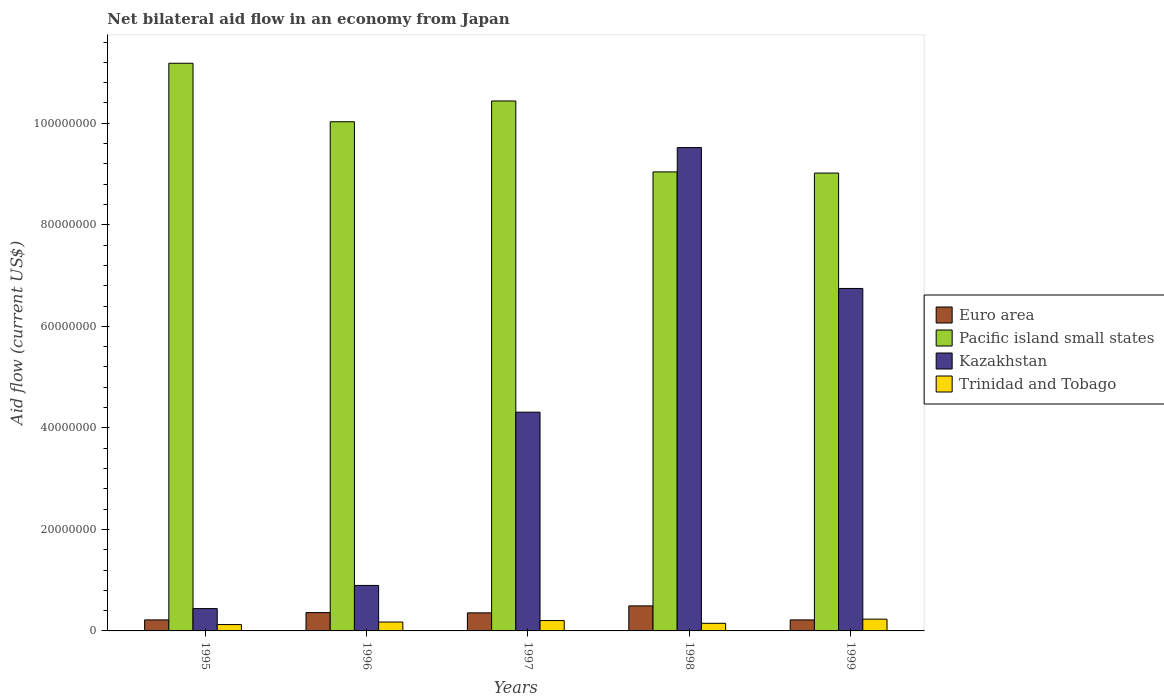How many different coloured bars are there?
Your answer should be compact. 4. How many groups of bars are there?
Offer a terse response. 5. Are the number of bars per tick equal to the number of legend labels?
Provide a succinct answer. Yes. Are the number of bars on each tick of the X-axis equal?
Make the answer very short. Yes. What is the net bilateral aid flow in Kazakhstan in 1996?
Your response must be concise. 8.96e+06. Across all years, what is the maximum net bilateral aid flow in Pacific island small states?
Make the answer very short. 1.12e+08. Across all years, what is the minimum net bilateral aid flow in Trinidad and Tobago?
Keep it short and to the point. 1.25e+06. In which year was the net bilateral aid flow in Kazakhstan maximum?
Give a very brief answer. 1998. What is the total net bilateral aid flow in Kazakhstan in the graph?
Ensure brevity in your answer.  2.19e+08. What is the difference between the net bilateral aid flow in Trinidad and Tobago in 1995 and that in 1997?
Offer a very short reply. -7.90e+05. What is the difference between the net bilateral aid flow in Pacific island small states in 1997 and the net bilateral aid flow in Kazakhstan in 1995?
Your response must be concise. 1.00e+08. What is the average net bilateral aid flow in Trinidad and Tobago per year?
Keep it short and to the point. 1.77e+06. What is the ratio of the net bilateral aid flow in Pacific island small states in 1997 to that in 1999?
Make the answer very short. 1.16. Is the net bilateral aid flow in Trinidad and Tobago in 1995 less than that in 1996?
Ensure brevity in your answer.  Yes. Is the difference between the net bilateral aid flow in Euro area in 1995 and 1998 greater than the difference between the net bilateral aid flow in Trinidad and Tobago in 1995 and 1998?
Offer a terse response. No. What is the difference between the highest and the second highest net bilateral aid flow in Pacific island small states?
Ensure brevity in your answer.  7.43e+06. What is the difference between the highest and the lowest net bilateral aid flow in Trinidad and Tobago?
Keep it short and to the point. 1.07e+06. What does the 4th bar from the left in 1998 represents?
Provide a succinct answer. Trinidad and Tobago. What does the 1st bar from the right in 1995 represents?
Provide a short and direct response. Trinidad and Tobago. How many bars are there?
Your answer should be compact. 20. Does the graph contain any zero values?
Provide a short and direct response. No. Does the graph contain grids?
Keep it short and to the point. No. What is the title of the graph?
Give a very brief answer. Net bilateral aid flow in an economy from Japan. Does "Norway" appear as one of the legend labels in the graph?
Provide a short and direct response. No. What is the label or title of the X-axis?
Provide a succinct answer. Years. What is the label or title of the Y-axis?
Your response must be concise. Aid flow (current US$). What is the Aid flow (current US$) of Euro area in 1995?
Ensure brevity in your answer.  2.17e+06. What is the Aid flow (current US$) in Pacific island small states in 1995?
Offer a terse response. 1.12e+08. What is the Aid flow (current US$) of Kazakhstan in 1995?
Provide a succinct answer. 4.40e+06. What is the Aid flow (current US$) in Trinidad and Tobago in 1995?
Ensure brevity in your answer.  1.25e+06. What is the Aid flow (current US$) in Euro area in 1996?
Provide a succinct answer. 3.61e+06. What is the Aid flow (current US$) in Pacific island small states in 1996?
Offer a terse response. 1.00e+08. What is the Aid flow (current US$) in Kazakhstan in 1996?
Ensure brevity in your answer.  8.96e+06. What is the Aid flow (current US$) in Trinidad and Tobago in 1996?
Provide a short and direct response. 1.75e+06. What is the Aid flow (current US$) in Euro area in 1997?
Your response must be concise. 3.56e+06. What is the Aid flow (current US$) in Pacific island small states in 1997?
Keep it short and to the point. 1.04e+08. What is the Aid flow (current US$) in Kazakhstan in 1997?
Ensure brevity in your answer.  4.31e+07. What is the Aid flow (current US$) in Trinidad and Tobago in 1997?
Your answer should be very brief. 2.04e+06. What is the Aid flow (current US$) of Euro area in 1998?
Keep it short and to the point. 4.93e+06. What is the Aid flow (current US$) in Pacific island small states in 1998?
Provide a succinct answer. 9.04e+07. What is the Aid flow (current US$) in Kazakhstan in 1998?
Ensure brevity in your answer.  9.52e+07. What is the Aid flow (current US$) in Trinidad and Tobago in 1998?
Provide a succinct answer. 1.50e+06. What is the Aid flow (current US$) of Euro area in 1999?
Make the answer very short. 2.17e+06. What is the Aid flow (current US$) of Pacific island small states in 1999?
Offer a very short reply. 9.02e+07. What is the Aid flow (current US$) in Kazakhstan in 1999?
Provide a succinct answer. 6.75e+07. What is the Aid flow (current US$) of Trinidad and Tobago in 1999?
Your answer should be very brief. 2.32e+06. Across all years, what is the maximum Aid flow (current US$) in Euro area?
Offer a terse response. 4.93e+06. Across all years, what is the maximum Aid flow (current US$) in Pacific island small states?
Ensure brevity in your answer.  1.12e+08. Across all years, what is the maximum Aid flow (current US$) of Kazakhstan?
Your answer should be very brief. 9.52e+07. Across all years, what is the maximum Aid flow (current US$) in Trinidad and Tobago?
Offer a very short reply. 2.32e+06. Across all years, what is the minimum Aid flow (current US$) in Euro area?
Keep it short and to the point. 2.17e+06. Across all years, what is the minimum Aid flow (current US$) in Pacific island small states?
Your answer should be compact. 9.02e+07. Across all years, what is the minimum Aid flow (current US$) of Kazakhstan?
Provide a short and direct response. 4.40e+06. Across all years, what is the minimum Aid flow (current US$) of Trinidad and Tobago?
Ensure brevity in your answer.  1.25e+06. What is the total Aid flow (current US$) in Euro area in the graph?
Your answer should be compact. 1.64e+07. What is the total Aid flow (current US$) in Pacific island small states in the graph?
Provide a succinct answer. 4.97e+08. What is the total Aid flow (current US$) of Kazakhstan in the graph?
Your answer should be very brief. 2.19e+08. What is the total Aid flow (current US$) in Trinidad and Tobago in the graph?
Your response must be concise. 8.86e+06. What is the difference between the Aid flow (current US$) in Euro area in 1995 and that in 1996?
Offer a very short reply. -1.44e+06. What is the difference between the Aid flow (current US$) of Pacific island small states in 1995 and that in 1996?
Ensure brevity in your answer.  1.15e+07. What is the difference between the Aid flow (current US$) of Kazakhstan in 1995 and that in 1996?
Your answer should be very brief. -4.56e+06. What is the difference between the Aid flow (current US$) in Trinidad and Tobago in 1995 and that in 1996?
Keep it short and to the point. -5.00e+05. What is the difference between the Aid flow (current US$) in Euro area in 1995 and that in 1997?
Offer a terse response. -1.39e+06. What is the difference between the Aid flow (current US$) in Pacific island small states in 1995 and that in 1997?
Give a very brief answer. 7.43e+06. What is the difference between the Aid flow (current US$) of Kazakhstan in 1995 and that in 1997?
Keep it short and to the point. -3.87e+07. What is the difference between the Aid flow (current US$) of Trinidad and Tobago in 1995 and that in 1997?
Offer a terse response. -7.90e+05. What is the difference between the Aid flow (current US$) in Euro area in 1995 and that in 1998?
Give a very brief answer. -2.76e+06. What is the difference between the Aid flow (current US$) of Pacific island small states in 1995 and that in 1998?
Your answer should be very brief. 2.14e+07. What is the difference between the Aid flow (current US$) of Kazakhstan in 1995 and that in 1998?
Your answer should be compact. -9.08e+07. What is the difference between the Aid flow (current US$) in Trinidad and Tobago in 1995 and that in 1998?
Provide a succinct answer. -2.50e+05. What is the difference between the Aid flow (current US$) of Pacific island small states in 1995 and that in 1999?
Provide a succinct answer. 2.16e+07. What is the difference between the Aid flow (current US$) of Kazakhstan in 1995 and that in 1999?
Your response must be concise. -6.31e+07. What is the difference between the Aid flow (current US$) of Trinidad and Tobago in 1995 and that in 1999?
Offer a terse response. -1.07e+06. What is the difference between the Aid flow (current US$) of Pacific island small states in 1996 and that in 1997?
Make the answer very short. -4.09e+06. What is the difference between the Aid flow (current US$) in Kazakhstan in 1996 and that in 1997?
Offer a very short reply. -3.41e+07. What is the difference between the Aid flow (current US$) in Euro area in 1996 and that in 1998?
Provide a succinct answer. -1.32e+06. What is the difference between the Aid flow (current US$) in Pacific island small states in 1996 and that in 1998?
Your response must be concise. 9.88e+06. What is the difference between the Aid flow (current US$) in Kazakhstan in 1996 and that in 1998?
Offer a terse response. -8.62e+07. What is the difference between the Aid flow (current US$) of Euro area in 1996 and that in 1999?
Give a very brief answer. 1.44e+06. What is the difference between the Aid flow (current US$) in Pacific island small states in 1996 and that in 1999?
Your answer should be compact. 1.01e+07. What is the difference between the Aid flow (current US$) in Kazakhstan in 1996 and that in 1999?
Provide a short and direct response. -5.85e+07. What is the difference between the Aid flow (current US$) of Trinidad and Tobago in 1996 and that in 1999?
Give a very brief answer. -5.70e+05. What is the difference between the Aid flow (current US$) of Euro area in 1997 and that in 1998?
Give a very brief answer. -1.37e+06. What is the difference between the Aid flow (current US$) in Pacific island small states in 1997 and that in 1998?
Provide a succinct answer. 1.40e+07. What is the difference between the Aid flow (current US$) of Kazakhstan in 1997 and that in 1998?
Your answer should be compact. -5.21e+07. What is the difference between the Aid flow (current US$) in Trinidad and Tobago in 1997 and that in 1998?
Offer a very short reply. 5.40e+05. What is the difference between the Aid flow (current US$) in Euro area in 1997 and that in 1999?
Provide a short and direct response. 1.39e+06. What is the difference between the Aid flow (current US$) of Pacific island small states in 1997 and that in 1999?
Provide a succinct answer. 1.42e+07. What is the difference between the Aid flow (current US$) in Kazakhstan in 1997 and that in 1999?
Give a very brief answer. -2.44e+07. What is the difference between the Aid flow (current US$) of Trinidad and Tobago in 1997 and that in 1999?
Provide a short and direct response. -2.80e+05. What is the difference between the Aid flow (current US$) in Euro area in 1998 and that in 1999?
Offer a terse response. 2.76e+06. What is the difference between the Aid flow (current US$) of Kazakhstan in 1998 and that in 1999?
Keep it short and to the point. 2.78e+07. What is the difference between the Aid flow (current US$) in Trinidad and Tobago in 1998 and that in 1999?
Your response must be concise. -8.20e+05. What is the difference between the Aid flow (current US$) in Euro area in 1995 and the Aid flow (current US$) in Pacific island small states in 1996?
Your response must be concise. -9.81e+07. What is the difference between the Aid flow (current US$) of Euro area in 1995 and the Aid flow (current US$) of Kazakhstan in 1996?
Provide a succinct answer. -6.79e+06. What is the difference between the Aid flow (current US$) of Euro area in 1995 and the Aid flow (current US$) of Trinidad and Tobago in 1996?
Your answer should be very brief. 4.20e+05. What is the difference between the Aid flow (current US$) in Pacific island small states in 1995 and the Aid flow (current US$) in Kazakhstan in 1996?
Your response must be concise. 1.03e+08. What is the difference between the Aid flow (current US$) of Pacific island small states in 1995 and the Aid flow (current US$) of Trinidad and Tobago in 1996?
Provide a short and direct response. 1.10e+08. What is the difference between the Aid flow (current US$) in Kazakhstan in 1995 and the Aid flow (current US$) in Trinidad and Tobago in 1996?
Give a very brief answer. 2.65e+06. What is the difference between the Aid flow (current US$) in Euro area in 1995 and the Aid flow (current US$) in Pacific island small states in 1997?
Your answer should be very brief. -1.02e+08. What is the difference between the Aid flow (current US$) of Euro area in 1995 and the Aid flow (current US$) of Kazakhstan in 1997?
Your answer should be very brief. -4.09e+07. What is the difference between the Aid flow (current US$) in Pacific island small states in 1995 and the Aid flow (current US$) in Kazakhstan in 1997?
Give a very brief answer. 6.87e+07. What is the difference between the Aid flow (current US$) of Pacific island small states in 1995 and the Aid flow (current US$) of Trinidad and Tobago in 1997?
Provide a short and direct response. 1.10e+08. What is the difference between the Aid flow (current US$) in Kazakhstan in 1995 and the Aid flow (current US$) in Trinidad and Tobago in 1997?
Keep it short and to the point. 2.36e+06. What is the difference between the Aid flow (current US$) of Euro area in 1995 and the Aid flow (current US$) of Pacific island small states in 1998?
Offer a terse response. -8.82e+07. What is the difference between the Aid flow (current US$) of Euro area in 1995 and the Aid flow (current US$) of Kazakhstan in 1998?
Ensure brevity in your answer.  -9.30e+07. What is the difference between the Aid flow (current US$) in Euro area in 1995 and the Aid flow (current US$) in Trinidad and Tobago in 1998?
Provide a succinct answer. 6.70e+05. What is the difference between the Aid flow (current US$) of Pacific island small states in 1995 and the Aid flow (current US$) of Kazakhstan in 1998?
Ensure brevity in your answer.  1.66e+07. What is the difference between the Aid flow (current US$) of Pacific island small states in 1995 and the Aid flow (current US$) of Trinidad and Tobago in 1998?
Ensure brevity in your answer.  1.10e+08. What is the difference between the Aid flow (current US$) of Kazakhstan in 1995 and the Aid flow (current US$) of Trinidad and Tobago in 1998?
Ensure brevity in your answer.  2.90e+06. What is the difference between the Aid flow (current US$) in Euro area in 1995 and the Aid flow (current US$) in Pacific island small states in 1999?
Your answer should be very brief. -8.80e+07. What is the difference between the Aid flow (current US$) in Euro area in 1995 and the Aid flow (current US$) in Kazakhstan in 1999?
Provide a succinct answer. -6.53e+07. What is the difference between the Aid flow (current US$) of Euro area in 1995 and the Aid flow (current US$) of Trinidad and Tobago in 1999?
Ensure brevity in your answer.  -1.50e+05. What is the difference between the Aid flow (current US$) in Pacific island small states in 1995 and the Aid flow (current US$) in Kazakhstan in 1999?
Your answer should be very brief. 4.44e+07. What is the difference between the Aid flow (current US$) of Pacific island small states in 1995 and the Aid flow (current US$) of Trinidad and Tobago in 1999?
Offer a terse response. 1.10e+08. What is the difference between the Aid flow (current US$) in Kazakhstan in 1995 and the Aid flow (current US$) in Trinidad and Tobago in 1999?
Keep it short and to the point. 2.08e+06. What is the difference between the Aid flow (current US$) in Euro area in 1996 and the Aid flow (current US$) in Pacific island small states in 1997?
Your answer should be compact. -1.01e+08. What is the difference between the Aid flow (current US$) in Euro area in 1996 and the Aid flow (current US$) in Kazakhstan in 1997?
Give a very brief answer. -3.95e+07. What is the difference between the Aid flow (current US$) in Euro area in 1996 and the Aid flow (current US$) in Trinidad and Tobago in 1997?
Your answer should be compact. 1.57e+06. What is the difference between the Aid flow (current US$) in Pacific island small states in 1996 and the Aid flow (current US$) in Kazakhstan in 1997?
Provide a short and direct response. 5.72e+07. What is the difference between the Aid flow (current US$) in Pacific island small states in 1996 and the Aid flow (current US$) in Trinidad and Tobago in 1997?
Offer a terse response. 9.83e+07. What is the difference between the Aid flow (current US$) of Kazakhstan in 1996 and the Aid flow (current US$) of Trinidad and Tobago in 1997?
Provide a succinct answer. 6.92e+06. What is the difference between the Aid flow (current US$) in Euro area in 1996 and the Aid flow (current US$) in Pacific island small states in 1998?
Provide a succinct answer. -8.68e+07. What is the difference between the Aid flow (current US$) in Euro area in 1996 and the Aid flow (current US$) in Kazakhstan in 1998?
Ensure brevity in your answer.  -9.16e+07. What is the difference between the Aid flow (current US$) of Euro area in 1996 and the Aid flow (current US$) of Trinidad and Tobago in 1998?
Ensure brevity in your answer.  2.11e+06. What is the difference between the Aid flow (current US$) in Pacific island small states in 1996 and the Aid flow (current US$) in Kazakhstan in 1998?
Your answer should be compact. 5.09e+06. What is the difference between the Aid flow (current US$) of Pacific island small states in 1996 and the Aid flow (current US$) of Trinidad and Tobago in 1998?
Make the answer very short. 9.88e+07. What is the difference between the Aid flow (current US$) in Kazakhstan in 1996 and the Aid flow (current US$) in Trinidad and Tobago in 1998?
Make the answer very short. 7.46e+06. What is the difference between the Aid flow (current US$) in Euro area in 1996 and the Aid flow (current US$) in Pacific island small states in 1999?
Your answer should be compact. -8.66e+07. What is the difference between the Aid flow (current US$) of Euro area in 1996 and the Aid flow (current US$) of Kazakhstan in 1999?
Ensure brevity in your answer.  -6.38e+07. What is the difference between the Aid flow (current US$) in Euro area in 1996 and the Aid flow (current US$) in Trinidad and Tobago in 1999?
Offer a terse response. 1.29e+06. What is the difference between the Aid flow (current US$) of Pacific island small states in 1996 and the Aid flow (current US$) of Kazakhstan in 1999?
Your answer should be very brief. 3.28e+07. What is the difference between the Aid flow (current US$) in Pacific island small states in 1996 and the Aid flow (current US$) in Trinidad and Tobago in 1999?
Give a very brief answer. 9.80e+07. What is the difference between the Aid flow (current US$) in Kazakhstan in 1996 and the Aid flow (current US$) in Trinidad and Tobago in 1999?
Your answer should be very brief. 6.64e+06. What is the difference between the Aid flow (current US$) of Euro area in 1997 and the Aid flow (current US$) of Pacific island small states in 1998?
Give a very brief answer. -8.69e+07. What is the difference between the Aid flow (current US$) of Euro area in 1997 and the Aid flow (current US$) of Kazakhstan in 1998?
Offer a very short reply. -9.16e+07. What is the difference between the Aid flow (current US$) in Euro area in 1997 and the Aid flow (current US$) in Trinidad and Tobago in 1998?
Make the answer very short. 2.06e+06. What is the difference between the Aid flow (current US$) in Pacific island small states in 1997 and the Aid flow (current US$) in Kazakhstan in 1998?
Give a very brief answer. 9.18e+06. What is the difference between the Aid flow (current US$) in Pacific island small states in 1997 and the Aid flow (current US$) in Trinidad and Tobago in 1998?
Provide a succinct answer. 1.03e+08. What is the difference between the Aid flow (current US$) of Kazakhstan in 1997 and the Aid flow (current US$) of Trinidad and Tobago in 1998?
Provide a short and direct response. 4.16e+07. What is the difference between the Aid flow (current US$) of Euro area in 1997 and the Aid flow (current US$) of Pacific island small states in 1999?
Your answer should be compact. -8.66e+07. What is the difference between the Aid flow (current US$) in Euro area in 1997 and the Aid flow (current US$) in Kazakhstan in 1999?
Provide a short and direct response. -6.39e+07. What is the difference between the Aid flow (current US$) of Euro area in 1997 and the Aid flow (current US$) of Trinidad and Tobago in 1999?
Offer a very short reply. 1.24e+06. What is the difference between the Aid flow (current US$) of Pacific island small states in 1997 and the Aid flow (current US$) of Kazakhstan in 1999?
Make the answer very short. 3.69e+07. What is the difference between the Aid flow (current US$) in Pacific island small states in 1997 and the Aid flow (current US$) in Trinidad and Tobago in 1999?
Ensure brevity in your answer.  1.02e+08. What is the difference between the Aid flow (current US$) in Kazakhstan in 1997 and the Aid flow (current US$) in Trinidad and Tobago in 1999?
Offer a very short reply. 4.08e+07. What is the difference between the Aid flow (current US$) of Euro area in 1998 and the Aid flow (current US$) of Pacific island small states in 1999?
Offer a terse response. -8.53e+07. What is the difference between the Aid flow (current US$) of Euro area in 1998 and the Aid flow (current US$) of Kazakhstan in 1999?
Your answer should be very brief. -6.25e+07. What is the difference between the Aid flow (current US$) of Euro area in 1998 and the Aid flow (current US$) of Trinidad and Tobago in 1999?
Give a very brief answer. 2.61e+06. What is the difference between the Aid flow (current US$) in Pacific island small states in 1998 and the Aid flow (current US$) in Kazakhstan in 1999?
Your response must be concise. 2.30e+07. What is the difference between the Aid flow (current US$) of Pacific island small states in 1998 and the Aid flow (current US$) of Trinidad and Tobago in 1999?
Offer a very short reply. 8.81e+07. What is the difference between the Aid flow (current US$) in Kazakhstan in 1998 and the Aid flow (current US$) in Trinidad and Tobago in 1999?
Keep it short and to the point. 9.29e+07. What is the average Aid flow (current US$) in Euro area per year?
Give a very brief answer. 3.29e+06. What is the average Aid flow (current US$) of Pacific island small states per year?
Keep it short and to the point. 9.94e+07. What is the average Aid flow (current US$) of Kazakhstan per year?
Give a very brief answer. 4.38e+07. What is the average Aid flow (current US$) of Trinidad and Tobago per year?
Provide a short and direct response. 1.77e+06. In the year 1995, what is the difference between the Aid flow (current US$) of Euro area and Aid flow (current US$) of Pacific island small states?
Provide a succinct answer. -1.10e+08. In the year 1995, what is the difference between the Aid flow (current US$) in Euro area and Aid flow (current US$) in Kazakhstan?
Offer a very short reply. -2.23e+06. In the year 1995, what is the difference between the Aid flow (current US$) of Euro area and Aid flow (current US$) of Trinidad and Tobago?
Keep it short and to the point. 9.20e+05. In the year 1995, what is the difference between the Aid flow (current US$) of Pacific island small states and Aid flow (current US$) of Kazakhstan?
Offer a terse response. 1.07e+08. In the year 1995, what is the difference between the Aid flow (current US$) in Pacific island small states and Aid flow (current US$) in Trinidad and Tobago?
Your answer should be very brief. 1.11e+08. In the year 1995, what is the difference between the Aid flow (current US$) of Kazakhstan and Aid flow (current US$) of Trinidad and Tobago?
Keep it short and to the point. 3.15e+06. In the year 1996, what is the difference between the Aid flow (current US$) in Euro area and Aid flow (current US$) in Pacific island small states?
Provide a succinct answer. -9.67e+07. In the year 1996, what is the difference between the Aid flow (current US$) of Euro area and Aid flow (current US$) of Kazakhstan?
Ensure brevity in your answer.  -5.35e+06. In the year 1996, what is the difference between the Aid flow (current US$) in Euro area and Aid flow (current US$) in Trinidad and Tobago?
Your answer should be very brief. 1.86e+06. In the year 1996, what is the difference between the Aid flow (current US$) of Pacific island small states and Aid flow (current US$) of Kazakhstan?
Keep it short and to the point. 9.13e+07. In the year 1996, what is the difference between the Aid flow (current US$) in Pacific island small states and Aid flow (current US$) in Trinidad and Tobago?
Offer a very short reply. 9.86e+07. In the year 1996, what is the difference between the Aid flow (current US$) of Kazakhstan and Aid flow (current US$) of Trinidad and Tobago?
Offer a terse response. 7.21e+06. In the year 1997, what is the difference between the Aid flow (current US$) in Euro area and Aid flow (current US$) in Pacific island small states?
Keep it short and to the point. -1.01e+08. In the year 1997, what is the difference between the Aid flow (current US$) in Euro area and Aid flow (current US$) in Kazakhstan?
Make the answer very short. -3.95e+07. In the year 1997, what is the difference between the Aid flow (current US$) in Euro area and Aid flow (current US$) in Trinidad and Tobago?
Your response must be concise. 1.52e+06. In the year 1997, what is the difference between the Aid flow (current US$) in Pacific island small states and Aid flow (current US$) in Kazakhstan?
Offer a terse response. 6.13e+07. In the year 1997, what is the difference between the Aid flow (current US$) of Pacific island small states and Aid flow (current US$) of Trinidad and Tobago?
Your answer should be very brief. 1.02e+08. In the year 1997, what is the difference between the Aid flow (current US$) in Kazakhstan and Aid flow (current US$) in Trinidad and Tobago?
Make the answer very short. 4.10e+07. In the year 1998, what is the difference between the Aid flow (current US$) in Euro area and Aid flow (current US$) in Pacific island small states?
Give a very brief answer. -8.55e+07. In the year 1998, what is the difference between the Aid flow (current US$) of Euro area and Aid flow (current US$) of Kazakhstan?
Your response must be concise. -9.03e+07. In the year 1998, what is the difference between the Aid flow (current US$) in Euro area and Aid flow (current US$) in Trinidad and Tobago?
Make the answer very short. 3.43e+06. In the year 1998, what is the difference between the Aid flow (current US$) of Pacific island small states and Aid flow (current US$) of Kazakhstan?
Provide a short and direct response. -4.79e+06. In the year 1998, what is the difference between the Aid flow (current US$) of Pacific island small states and Aid flow (current US$) of Trinidad and Tobago?
Provide a short and direct response. 8.89e+07. In the year 1998, what is the difference between the Aid flow (current US$) of Kazakhstan and Aid flow (current US$) of Trinidad and Tobago?
Keep it short and to the point. 9.37e+07. In the year 1999, what is the difference between the Aid flow (current US$) in Euro area and Aid flow (current US$) in Pacific island small states?
Make the answer very short. -8.80e+07. In the year 1999, what is the difference between the Aid flow (current US$) in Euro area and Aid flow (current US$) in Kazakhstan?
Keep it short and to the point. -6.53e+07. In the year 1999, what is the difference between the Aid flow (current US$) of Euro area and Aid flow (current US$) of Trinidad and Tobago?
Provide a succinct answer. -1.50e+05. In the year 1999, what is the difference between the Aid flow (current US$) of Pacific island small states and Aid flow (current US$) of Kazakhstan?
Your response must be concise. 2.27e+07. In the year 1999, what is the difference between the Aid flow (current US$) in Pacific island small states and Aid flow (current US$) in Trinidad and Tobago?
Your answer should be compact. 8.79e+07. In the year 1999, what is the difference between the Aid flow (current US$) of Kazakhstan and Aid flow (current US$) of Trinidad and Tobago?
Your answer should be very brief. 6.51e+07. What is the ratio of the Aid flow (current US$) in Euro area in 1995 to that in 1996?
Provide a short and direct response. 0.6. What is the ratio of the Aid flow (current US$) in Pacific island small states in 1995 to that in 1996?
Provide a succinct answer. 1.11. What is the ratio of the Aid flow (current US$) in Kazakhstan in 1995 to that in 1996?
Your answer should be compact. 0.49. What is the ratio of the Aid flow (current US$) of Trinidad and Tobago in 1995 to that in 1996?
Offer a very short reply. 0.71. What is the ratio of the Aid flow (current US$) of Euro area in 1995 to that in 1997?
Your response must be concise. 0.61. What is the ratio of the Aid flow (current US$) of Pacific island small states in 1995 to that in 1997?
Provide a short and direct response. 1.07. What is the ratio of the Aid flow (current US$) in Kazakhstan in 1995 to that in 1997?
Your answer should be compact. 0.1. What is the ratio of the Aid flow (current US$) of Trinidad and Tobago in 1995 to that in 1997?
Provide a short and direct response. 0.61. What is the ratio of the Aid flow (current US$) of Euro area in 1995 to that in 1998?
Offer a very short reply. 0.44. What is the ratio of the Aid flow (current US$) in Pacific island small states in 1995 to that in 1998?
Provide a short and direct response. 1.24. What is the ratio of the Aid flow (current US$) in Kazakhstan in 1995 to that in 1998?
Your answer should be compact. 0.05. What is the ratio of the Aid flow (current US$) of Trinidad and Tobago in 1995 to that in 1998?
Provide a short and direct response. 0.83. What is the ratio of the Aid flow (current US$) in Pacific island small states in 1995 to that in 1999?
Keep it short and to the point. 1.24. What is the ratio of the Aid flow (current US$) in Kazakhstan in 1995 to that in 1999?
Your answer should be compact. 0.07. What is the ratio of the Aid flow (current US$) of Trinidad and Tobago in 1995 to that in 1999?
Ensure brevity in your answer.  0.54. What is the ratio of the Aid flow (current US$) of Euro area in 1996 to that in 1997?
Keep it short and to the point. 1.01. What is the ratio of the Aid flow (current US$) in Pacific island small states in 1996 to that in 1997?
Offer a terse response. 0.96. What is the ratio of the Aid flow (current US$) in Kazakhstan in 1996 to that in 1997?
Provide a succinct answer. 0.21. What is the ratio of the Aid flow (current US$) of Trinidad and Tobago in 1996 to that in 1997?
Provide a succinct answer. 0.86. What is the ratio of the Aid flow (current US$) of Euro area in 1996 to that in 1998?
Make the answer very short. 0.73. What is the ratio of the Aid flow (current US$) in Pacific island small states in 1996 to that in 1998?
Provide a short and direct response. 1.11. What is the ratio of the Aid flow (current US$) of Kazakhstan in 1996 to that in 1998?
Provide a succinct answer. 0.09. What is the ratio of the Aid flow (current US$) of Euro area in 1996 to that in 1999?
Your response must be concise. 1.66. What is the ratio of the Aid flow (current US$) of Pacific island small states in 1996 to that in 1999?
Keep it short and to the point. 1.11. What is the ratio of the Aid flow (current US$) of Kazakhstan in 1996 to that in 1999?
Make the answer very short. 0.13. What is the ratio of the Aid flow (current US$) in Trinidad and Tobago in 1996 to that in 1999?
Provide a short and direct response. 0.75. What is the ratio of the Aid flow (current US$) of Euro area in 1997 to that in 1998?
Your answer should be very brief. 0.72. What is the ratio of the Aid flow (current US$) of Pacific island small states in 1997 to that in 1998?
Make the answer very short. 1.15. What is the ratio of the Aid flow (current US$) of Kazakhstan in 1997 to that in 1998?
Ensure brevity in your answer.  0.45. What is the ratio of the Aid flow (current US$) of Trinidad and Tobago in 1997 to that in 1998?
Give a very brief answer. 1.36. What is the ratio of the Aid flow (current US$) in Euro area in 1997 to that in 1999?
Your response must be concise. 1.64. What is the ratio of the Aid flow (current US$) in Pacific island small states in 1997 to that in 1999?
Offer a very short reply. 1.16. What is the ratio of the Aid flow (current US$) of Kazakhstan in 1997 to that in 1999?
Offer a terse response. 0.64. What is the ratio of the Aid flow (current US$) of Trinidad and Tobago in 1997 to that in 1999?
Offer a terse response. 0.88. What is the ratio of the Aid flow (current US$) of Euro area in 1998 to that in 1999?
Offer a terse response. 2.27. What is the ratio of the Aid flow (current US$) in Pacific island small states in 1998 to that in 1999?
Your response must be concise. 1. What is the ratio of the Aid flow (current US$) in Kazakhstan in 1998 to that in 1999?
Offer a terse response. 1.41. What is the ratio of the Aid flow (current US$) of Trinidad and Tobago in 1998 to that in 1999?
Give a very brief answer. 0.65. What is the difference between the highest and the second highest Aid flow (current US$) of Euro area?
Your response must be concise. 1.32e+06. What is the difference between the highest and the second highest Aid flow (current US$) of Pacific island small states?
Your answer should be compact. 7.43e+06. What is the difference between the highest and the second highest Aid flow (current US$) in Kazakhstan?
Give a very brief answer. 2.78e+07. What is the difference between the highest and the second highest Aid flow (current US$) of Trinidad and Tobago?
Make the answer very short. 2.80e+05. What is the difference between the highest and the lowest Aid flow (current US$) in Euro area?
Provide a succinct answer. 2.76e+06. What is the difference between the highest and the lowest Aid flow (current US$) of Pacific island small states?
Your answer should be compact. 2.16e+07. What is the difference between the highest and the lowest Aid flow (current US$) of Kazakhstan?
Keep it short and to the point. 9.08e+07. What is the difference between the highest and the lowest Aid flow (current US$) of Trinidad and Tobago?
Give a very brief answer. 1.07e+06. 